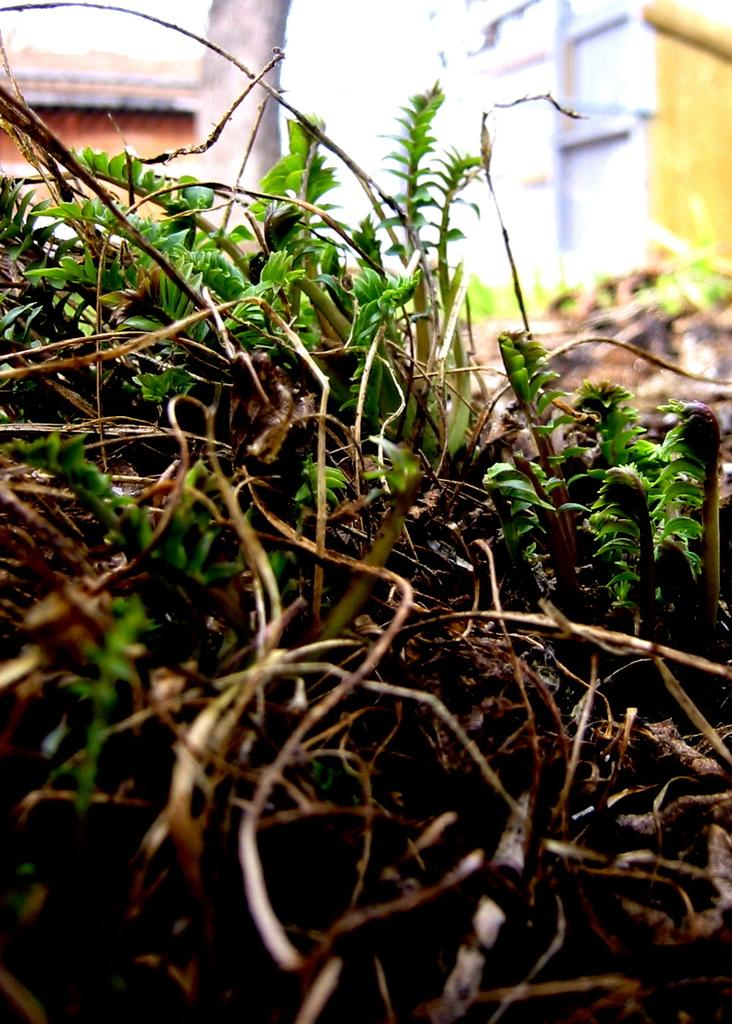What type of living organisms can be seen in the image? Plants and a tree are visible in the image. What can be seen in the background of the image? Buildings are visible in the background of the image. What type of boat is visible in the image? There is no boat present in the image. What suggestion can be made to improve the appearance of the plants in the image? The image does not require any suggestions for improvement, as it is a static representation. 